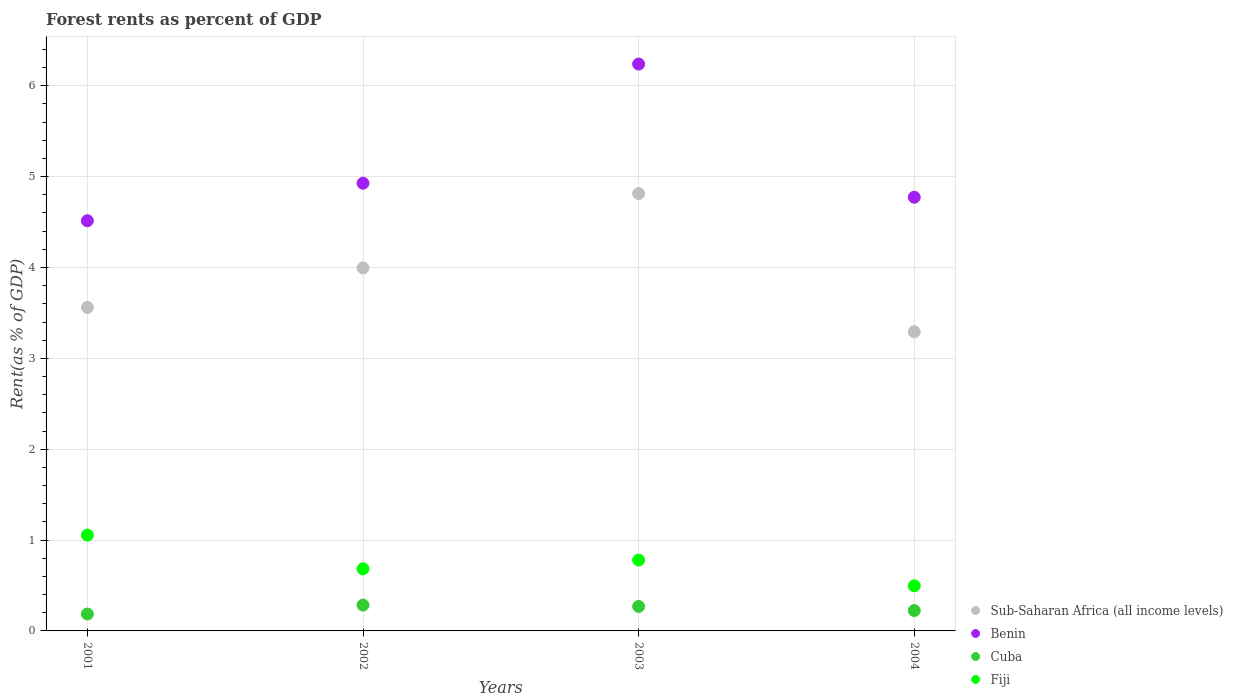Is the number of dotlines equal to the number of legend labels?
Offer a terse response. Yes. What is the forest rent in Fiji in 2001?
Your response must be concise. 1.05. Across all years, what is the maximum forest rent in Benin?
Ensure brevity in your answer.  6.24. Across all years, what is the minimum forest rent in Cuba?
Offer a terse response. 0.19. In which year was the forest rent in Fiji maximum?
Ensure brevity in your answer.  2001. What is the total forest rent in Sub-Saharan Africa (all income levels) in the graph?
Your response must be concise. 15.66. What is the difference between the forest rent in Benin in 2002 and that in 2004?
Give a very brief answer. 0.15. What is the difference between the forest rent in Fiji in 2002 and the forest rent in Sub-Saharan Africa (all income levels) in 2001?
Make the answer very short. -2.88. What is the average forest rent in Benin per year?
Your answer should be very brief. 5.11. In the year 2001, what is the difference between the forest rent in Sub-Saharan Africa (all income levels) and forest rent in Benin?
Provide a short and direct response. -0.95. In how many years, is the forest rent in Fiji greater than 3.8 %?
Your answer should be compact. 0. What is the ratio of the forest rent in Sub-Saharan Africa (all income levels) in 2001 to that in 2002?
Give a very brief answer. 0.89. Is the forest rent in Sub-Saharan Africa (all income levels) in 2002 less than that in 2003?
Make the answer very short. Yes. What is the difference between the highest and the second highest forest rent in Fiji?
Give a very brief answer. 0.28. What is the difference between the highest and the lowest forest rent in Fiji?
Ensure brevity in your answer.  0.56. In how many years, is the forest rent in Cuba greater than the average forest rent in Cuba taken over all years?
Your response must be concise. 2. Is the sum of the forest rent in Cuba in 2002 and 2003 greater than the maximum forest rent in Benin across all years?
Ensure brevity in your answer.  No. Is it the case that in every year, the sum of the forest rent in Sub-Saharan Africa (all income levels) and forest rent in Cuba  is greater than the sum of forest rent in Fiji and forest rent in Benin?
Offer a very short reply. No. Is the forest rent in Sub-Saharan Africa (all income levels) strictly greater than the forest rent in Fiji over the years?
Your answer should be very brief. Yes. Is the forest rent in Benin strictly less than the forest rent in Sub-Saharan Africa (all income levels) over the years?
Offer a terse response. No. Does the graph contain any zero values?
Your response must be concise. No. How many legend labels are there?
Provide a succinct answer. 4. How are the legend labels stacked?
Your response must be concise. Vertical. What is the title of the graph?
Provide a short and direct response. Forest rents as percent of GDP. What is the label or title of the Y-axis?
Give a very brief answer. Rent(as % of GDP). What is the Rent(as % of GDP) in Sub-Saharan Africa (all income levels) in 2001?
Give a very brief answer. 3.56. What is the Rent(as % of GDP) of Benin in 2001?
Give a very brief answer. 4.51. What is the Rent(as % of GDP) in Cuba in 2001?
Offer a terse response. 0.19. What is the Rent(as % of GDP) of Fiji in 2001?
Ensure brevity in your answer.  1.05. What is the Rent(as % of GDP) of Sub-Saharan Africa (all income levels) in 2002?
Your response must be concise. 4. What is the Rent(as % of GDP) of Benin in 2002?
Make the answer very short. 4.93. What is the Rent(as % of GDP) of Cuba in 2002?
Ensure brevity in your answer.  0.28. What is the Rent(as % of GDP) in Fiji in 2002?
Provide a short and direct response. 0.68. What is the Rent(as % of GDP) in Sub-Saharan Africa (all income levels) in 2003?
Your answer should be very brief. 4.81. What is the Rent(as % of GDP) of Benin in 2003?
Provide a short and direct response. 6.24. What is the Rent(as % of GDP) in Cuba in 2003?
Offer a terse response. 0.27. What is the Rent(as % of GDP) in Fiji in 2003?
Offer a very short reply. 0.78. What is the Rent(as % of GDP) in Sub-Saharan Africa (all income levels) in 2004?
Your answer should be very brief. 3.29. What is the Rent(as % of GDP) of Benin in 2004?
Your answer should be compact. 4.77. What is the Rent(as % of GDP) in Cuba in 2004?
Offer a very short reply. 0.22. What is the Rent(as % of GDP) of Fiji in 2004?
Provide a succinct answer. 0.5. Across all years, what is the maximum Rent(as % of GDP) of Sub-Saharan Africa (all income levels)?
Your response must be concise. 4.81. Across all years, what is the maximum Rent(as % of GDP) of Benin?
Your answer should be very brief. 6.24. Across all years, what is the maximum Rent(as % of GDP) of Cuba?
Offer a terse response. 0.28. Across all years, what is the maximum Rent(as % of GDP) in Fiji?
Ensure brevity in your answer.  1.05. Across all years, what is the minimum Rent(as % of GDP) of Sub-Saharan Africa (all income levels)?
Offer a terse response. 3.29. Across all years, what is the minimum Rent(as % of GDP) of Benin?
Ensure brevity in your answer.  4.51. Across all years, what is the minimum Rent(as % of GDP) of Cuba?
Make the answer very short. 0.19. Across all years, what is the minimum Rent(as % of GDP) of Fiji?
Ensure brevity in your answer.  0.5. What is the total Rent(as % of GDP) in Sub-Saharan Africa (all income levels) in the graph?
Offer a terse response. 15.66. What is the total Rent(as % of GDP) of Benin in the graph?
Provide a short and direct response. 20.45. What is the total Rent(as % of GDP) in Cuba in the graph?
Your answer should be very brief. 0.96. What is the total Rent(as % of GDP) of Fiji in the graph?
Your response must be concise. 3.01. What is the difference between the Rent(as % of GDP) of Sub-Saharan Africa (all income levels) in 2001 and that in 2002?
Offer a very short reply. -0.44. What is the difference between the Rent(as % of GDP) in Benin in 2001 and that in 2002?
Ensure brevity in your answer.  -0.41. What is the difference between the Rent(as % of GDP) of Cuba in 2001 and that in 2002?
Your answer should be very brief. -0.1. What is the difference between the Rent(as % of GDP) in Fiji in 2001 and that in 2002?
Give a very brief answer. 0.37. What is the difference between the Rent(as % of GDP) in Sub-Saharan Africa (all income levels) in 2001 and that in 2003?
Ensure brevity in your answer.  -1.25. What is the difference between the Rent(as % of GDP) in Benin in 2001 and that in 2003?
Provide a short and direct response. -1.72. What is the difference between the Rent(as % of GDP) in Cuba in 2001 and that in 2003?
Make the answer very short. -0.08. What is the difference between the Rent(as % of GDP) of Fiji in 2001 and that in 2003?
Give a very brief answer. 0.28. What is the difference between the Rent(as % of GDP) in Sub-Saharan Africa (all income levels) in 2001 and that in 2004?
Ensure brevity in your answer.  0.27. What is the difference between the Rent(as % of GDP) of Benin in 2001 and that in 2004?
Give a very brief answer. -0.26. What is the difference between the Rent(as % of GDP) in Cuba in 2001 and that in 2004?
Ensure brevity in your answer.  -0.04. What is the difference between the Rent(as % of GDP) of Fiji in 2001 and that in 2004?
Your response must be concise. 0.56. What is the difference between the Rent(as % of GDP) in Sub-Saharan Africa (all income levels) in 2002 and that in 2003?
Offer a terse response. -0.82. What is the difference between the Rent(as % of GDP) in Benin in 2002 and that in 2003?
Offer a terse response. -1.31. What is the difference between the Rent(as % of GDP) of Cuba in 2002 and that in 2003?
Give a very brief answer. 0.02. What is the difference between the Rent(as % of GDP) of Fiji in 2002 and that in 2003?
Keep it short and to the point. -0.1. What is the difference between the Rent(as % of GDP) in Sub-Saharan Africa (all income levels) in 2002 and that in 2004?
Offer a terse response. 0.7. What is the difference between the Rent(as % of GDP) of Benin in 2002 and that in 2004?
Give a very brief answer. 0.15. What is the difference between the Rent(as % of GDP) in Cuba in 2002 and that in 2004?
Provide a succinct answer. 0.06. What is the difference between the Rent(as % of GDP) in Fiji in 2002 and that in 2004?
Provide a succinct answer. 0.19. What is the difference between the Rent(as % of GDP) in Sub-Saharan Africa (all income levels) in 2003 and that in 2004?
Keep it short and to the point. 1.52. What is the difference between the Rent(as % of GDP) of Benin in 2003 and that in 2004?
Give a very brief answer. 1.47. What is the difference between the Rent(as % of GDP) in Cuba in 2003 and that in 2004?
Offer a terse response. 0.05. What is the difference between the Rent(as % of GDP) of Fiji in 2003 and that in 2004?
Make the answer very short. 0.28. What is the difference between the Rent(as % of GDP) of Sub-Saharan Africa (all income levels) in 2001 and the Rent(as % of GDP) of Benin in 2002?
Give a very brief answer. -1.37. What is the difference between the Rent(as % of GDP) in Sub-Saharan Africa (all income levels) in 2001 and the Rent(as % of GDP) in Cuba in 2002?
Offer a terse response. 3.28. What is the difference between the Rent(as % of GDP) in Sub-Saharan Africa (all income levels) in 2001 and the Rent(as % of GDP) in Fiji in 2002?
Your answer should be compact. 2.88. What is the difference between the Rent(as % of GDP) in Benin in 2001 and the Rent(as % of GDP) in Cuba in 2002?
Offer a very short reply. 4.23. What is the difference between the Rent(as % of GDP) of Benin in 2001 and the Rent(as % of GDP) of Fiji in 2002?
Provide a succinct answer. 3.83. What is the difference between the Rent(as % of GDP) of Cuba in 2001 and the Rent(as % of GDP) of Fiji in 2002?
Offer a very short reply. -0.5. What is the difference between the Rent(as % of GDP) in Sub-Saharan Africa (all income levels) in 2001 and the Rent(as % of GDP) in Benin in 2003?
Your answer should be very brief. -2.68. What is the difference between the Rent(as % of GDP) in Sub-Saharan Africa (all income levels) in 2001 and the Rent(as % of GDP) in Cuba in 2003?
Keep it short and to the point. 3.29. What is the difference between the Rent(as % of GDP) of Sub-Saharan Africa (all income levels) in 2001 and the Rent(as % of GDP) of Fiji in 2003?
Make the answer very short. 2.78. What is the difference between the Rent(as % of GDP) of Benin in 2001 and the Rent(as % of GDP) of Cuba in 2003?
Give a very brief answer. 4.25. What is the difference between the Rent(as % of GDP) of Benin in 2001 and the Rent(as % of GDP) of Fiji in 2003?
Give a very brief answer. 3.73. What is the difference between the Rent(as % of GDP) of Cuba in 2001 and the Rent(as % of GDP) of Fiji in 2003?
Your answer should be compact. -0.59. What is the difference between the Rent(as % of GDP) of Sub-Saharan Africa (all income levels) in 2001 and the Rent(as % of GDP) of Benin in 2004?
Your answer should be compact. -1.21. What is the difference between the Rent(as % of GDP) of Sub-Saharan Africa (all income levels) in 2001 and the Rent(as % of GDP) of Cuba in 2004?
Offer a very short reply. 3.34. What is the difference between the Rent(as % of GDP) of Sub-Saharan Africa (all income levels) in 2001 and the Rent(as % of GDP) of Fiji in 2004?
Give a very brief answer. 3.06. What is the difference between the Rent(as % of GDP) in Benin in 2001 and the Rent(as % of GDP) in Cuba in 2004?
Ensure brevity in your answer.  4.29. What is the difference between the Rent(as % of GDP) of Benin in 2001 and the Rent(as % of GDP) of Fiji in 2004?
Offer a very short reply. 4.02. What is the difference between the Rent(as % of GDP) in Cuba in 2001 and the Rent(as % of GDP) in Fiji in 2004?
Offer a very short reply. -0.31. What is the difference between the Rent(as % of GDP) of Sub-Saharan Africa (all income levels) in 2002 and the Rent(as % of GDP) of Benin in 2003?
Your response must be concise. -2.24. What is the difference between the Rent(as % of GDP) in Sub-Saharan Africa (all income levels) in 2002 and the Rent(as % of GDP) in Cuba in 2003?
Your response must be concise. 3.73. What is the difference between the Rent(as % of GDP) in Sub-Saharan Africa (all income levels) in 2002 and the Rent(as % of GDP) in Fiji in 2003?
Provide a short and direct response. 3.22. What is the difference between the Rent(as % of GDP) in Benin in 2002 and the Rent(as % of GDP) in Cuba in 2003?
Your answer should be compact. 4.66. What is the difference between the Rent(as % of GDP) in Benin in 2002 and the Rent(as % of GDP) in Fiji in 2003?
Offer a very short reply. 4.15. What is the difference between the Rent(as % of GDP) of Cuba in 2002 and the Rent(as % of GDP) of Fiji in 2003?
Your answer should be compact. -0.5. What is the difference between the Rent(as % of GDP) of Sub-Saharan Africa (all income levels) in 2002 and the Rent(as % of GDP) of Benin in 2004?
Offer a very short reply. -0.78. What is the difference between the Rent(as % of GDP) of Sub-Saharan Africa (all income levels) in 2002 and the Rent(as % of GDP) of Cuba in 2004?
Your answer should be compact. 3.77. What is the difference between the Rent(as % of GDP) in Sub-Saharan Africa (all income levels) in 2002 and the Rent(as % of GDP) in Fiji in 2004?
Provide a succinct answer. 3.5. What is the difference between the Rent(as % of GDP) of Benin in 2002 and the Rent(as % of GDP) of Cuba in 2004?
Your response must be concise. 4.7. What is the difference between the Rent(as % of GDP) in Benin in 2002 and the Rent(as % of GDP) in Fiji in 2004?
Your answer should be very brief. 4.43. What is the difference between the Rent(as % of GDP) in Cuba in 2002 and the Rent(as % of GDP) in Fiji in 2004?
Keep it short and to the point. -0.21. What is the difference between the Rent(as % of GDP) in Sub-Saharan Africa (all income levels) in 2003 and the Rent(as % of GDP) in Benin in 2004?
Make the answer very short. 0.04. What is the difference between the Rent(as % of GDP) in Sub-Saharan Africa (all income levels) in 2003 and the Rent(as % of GDP) in Cuba in 2004?
Your answer should be very brief. 4.59. What is the difference between the Rent(as % of GDP) in Sub-Saharan Africa (all income levels) in 2003 and the Rent(as % of GDP) in Fiji in 2004?
Keep it short and to the point. 4.32. What is the difference between the Rent(as % of GDP) in Benin in 2003 and the Rent(as % of GDP) in Cuba in 2004?
Offer a very short reply. 6.01. What is the difference between the Rent(as % of GDP) in Benin in 2003 and the Rent(as % of GDP) in Fiji in 2004?
Make the answer very short. 5.74. What is the difference between the Rent(as % of GDP) in Cuba in 2003 and the Rent(as % of GDP) in Fiji in 2004?
Provide a succinct answer. -0.23. What is the average Rent(as % of GDP) of Sub-Saharan Africa (all income levels) per year?
Your response must be concise. 3.92. What is the average Rent(as % of GDP) of Benin per year?
Offer a terse response. 5.11. What is the average Rent(as % of GDP) in Cuba per year?
Offer a very short reply. 0.24. What is the average Rent(as % of GDP) in Fiji per year?
Make the answer very short. 0.75. In the year 2001, what is the difference between the Rent(as % of GDP) in Sub-Saharan Africa (all income levels) and Rent(as % of GDP) in Benin?
Offer a terse response. -0.95. In the year 2001, what is the difference between the Rent(as % of GDP) of Sub-Saharan Africa (all income levels) and Rent(as % of GDP) of Cuba?
Keep it short and to the point. 3.37. In the year 2001, what is the difference between the Rent(as % of GDP) of Sub-Saharan Africa (all income levels) and Rent(as % of GDP) of Fiji?
Your answer should be compact. 2.51. In the year 2001, what is the difference between the Rent(as % of GDP) of Benin and Rent(as % of GDP) of Cuba?
Make the answer very short. 4.33. In the year 2001, what is the difference between the Rent(as % of GDP) of Benin and Rent(as % of GDP) of Fiji?
Provide a short and direct response. 3.46. In the year 2001, what is the difference between the Rent(as % of GDP) of Cuba and Rent(as % of GDP) of Fiji?
Offer a very short reply. -0.87. In the year 2002, what is the difference between the Rent(as % of GDP) of Sub-Saharan Africa (all income levels) and Rent(as % of GDP) of Benin?
Provide a succinct answer. -0.93. In the year 2002, what is the difference between the Rent(as % of GDP) in Sub-Saharan Africa (all income levels) and Rent(as % of GDP) in Cuba?
Give a very brief answer. 3.71. In the year 2002, what is the difference between the Rent(as % of GDP) in Sub-Saharan Africa (all income levels) and Rent(as % of GDP) in Fiji?
Make the answer very short. 3.31. In the year 2002, what is the difference between the Rent(as % of GDP) in Benin and Rent(as % of GDP) in Cuba?
Keep it short and to the point. 4.64. In the year 2002, what is the difference between the Rent(as % of GDP) in Benin and Rent(as % of GDP) in Fiji?
Ensure brevity in your answer.  4.24. In the year 2002, what is the difference between the Rent(as % of GDP) in Cuba and Rent(as % of GDP) in Fiji?
Provide a short and direct response. -0.4. In the year 2003, what is the difference between the Rent(as % of GDP) in Sub-Saharan Africa (all income levels) and Rent(as % of GDP) in Benin?
Your answer should be compact. -1.42. In the year 2003, what is the difference between the Rent(as % of GDP) of Sub-Saharan Africa (all income levels) and Rent(as % of GDP) of Cuba?
Your response must be concise. 4.54. In the year 2003, what is the difference between the Rent(as % of GDP) of Sub-Saharan Africa (all income levels) and Rent(as % of GDP) of Fiji?
Your answer should be compact. 4.03. In the year 2003, what is the difference between the Rent(as % of GDP) of Benin and Rent(as % of GDP) of Cuba?
Your answer should be very brief. 5.97. In the year 2003, what is the difference between the Rent(as % of GDP) in Benin and Rent(as % of GDP) in Fiji?
Offer a terse response. 5.46. In the year 2003, what is the difference between the Rent(as % of GDP) in Cuba and Rent(as % of GDP) in Fiji?
Give a very brief answer. -0.51. In the year 2004, what is the difference between the Rent(as % of GDP) in Sub-Saharan Africa (all income levels) and Rent(as % of GDP) in Benin?
Provide a succinct answer. -1.48. In the year 2004, what is the difference between the Rent(as % of GDP) of Sub-Saharan Africa (all income levels) and Rent(as % of GDP) of Cuba?
Your answer should be very brief. 3.07. In the year 2004, what is the difference between the Rent(as % of GDP) in Sub-Saharan Africa (all income levels) and Rent(as % of GDP) in Fiji?
Provide a short and direct response. 2.8. In the year 2004, what is the difference between the Rent(as % of GDP) in Benin and Rent(as % of GDP) in Cuba?
Your answer should be very brief. 4.55. In the year 2004, what is the difference between the Rent(as % of GDP) in Benin and Rent(as % of GDP) in Fiji?
Offer a terse response. 4.28. In the year 2004, what is the difference between the Rent(as % of GDP) in Cuba and Rent(as % of GDP) in Fiji?
Keep it short and to the point. -0.27. What is the ratio of the Rent(as % of GDP) of Sub-Saharan Africa (all income levels) in 2001 to that in 2002?
Offer a terse response. 0.89. What is the ratio of the Rent(as % of GDP) in Benin in 2001 to that in 2002?
Ensure brevity in your answer.  0.92. What is the ratio of the Rent(as % of GDP) in Cuba in 2001 to that in 2002?
Offer a very short reply. 0.65. What is the ratio of the Rent(as % of GDP) in Fiji in 2001 to that in 2002?
Offer a terse response. 1.54. What is the ratio of the Rent(as % of GDP) of Sub-Saharan Africa (all income levels) in 2001 to that in 2003?
Make the answer very short. 0.74. What is the ratio of the Rent(as % of GDP) of Benin in 2001 to that in 2003?
Keep it short and to the point. 0.72. What is the ratio of the Rent(as % of GDP) of Cuba in 2001 to that in 2003?
Provide a succinct answer. 0.69. What is the ratio of the Rent(as % of GDP) in Fiji in 2001 to that in 2003?
Ensure brevity in your answer.  1.35. What is the ratio of the Rent(as % of GDP) of Sub-Saharan Africa (all income levels) in 2001 to that in 2004?
Your answer should be compact. 1.08. What is the ratio of the Rent(as % of GDP) of Benin in 2001 to that in 2004?
Keep it short and to the point. 0.95. What is the ratio of the Rent(as % of GDP) of Cuba in 2001 to that in 2004?
Make the answer very short. 0.83. What is the ratio of the Rent(as % of GDP) of Fiji in 2001 to that in 2004?
Your answer should be very brief. 2.13. What is the ratio of the Rent(as % of GDP) in Sub-Saharan Africa (all income levels) in 2002 to that in 2003?
Offer a terse response. 0.83. What is the ratio of the Rent(as % of GDP) of Benin in 2002 to that in 2003?
Provide a succinct answer. 0.79. What is the ratio of the Rent(as % of GDP) of Cuba in 2002 to that in 2003?
Your answer should be very brief. 1.06. What is the ratio of the Rent(as % of GDP) in Fiji in 2002 to that in 2003?
Provide a short and direct response. 0.88. What is the ratio of the Rent(as % of GDP) of Sub-Saharan Africa (all income levels) in 2002 to that in 2004?
Make the answer very short. 1.21. What is the ratio of the Rent(as % of GDP) in Benin in 2002 to that in 2004?
Provide a succinct answer. 1.03. What is the ratio of the Rent(as % of GDP) of Cuba in 2002 to that in 2004?
Keep it short and to the point. 1.27. What is the ratio of the Rent(as % of GDP) in Fiji in 2002 to that in 2004?
Make the answer very short. 1.38. What is the ratio of the Rent(as % of GDP) of Sub-Saharan Africa (all income levels) in 2003 to that in 2004?
Provide a succinct answer. 1.46. What is the ratio of the Rent(as % of GDP) in Benin in 2003 to that in 2004?
Offer a very short reply. 1.31. What is the ratio of the Rent(as % of GDP) in Cuba in 2003 to that in 2004?
Provide a short and direct response. 1.2. What is the ratio of the Rent(as % of GDP) of Fiji in 2003 to that in 2004?
Make the answer very short. 1.57. What is the difference between the highest and the second highest Rent(as % of GDP) of Sub-Saharan Africa (all income levels)?
Provide a short and direct response. 0.82. What is the difference between the highest and the second highest Rent(as % of GDP) of Benin?
Give a very brief answer. 1.31. What is the difference between the highest and the second highest Rent(as % of GDP) in Cuba?
Ensure brevity in your answer.  0.02. What is the difference between the highest and the second highest Rent(as % of GDP) of Fiji?
Provide a succinct answer. 0.28. What is the difference between the highest and the lowest Rent(as % of GDP) of Sub-Saharan Africa (all income levels)?
Your answer should be very brief. 1.52. What is the difference between the highest and the lowest Rent(as % of GDP) of Benin?
Ensure brevity in your answer.  1.72. What is the difference between the highest and the lowest Rent(as % of GDP) of Cuba?
Provide a succinct answer. 0.1. What is the difference between the highest and the lowest Rent(as % of GDP) in Fiji?
Offer a terse response. 0.56. 